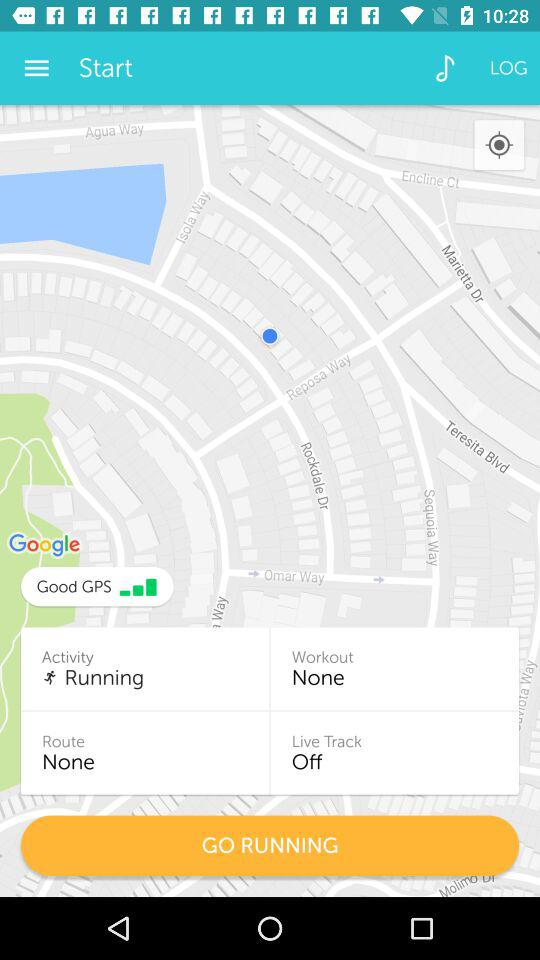What is the status of the "Live Track"? The status of the "Live Track" is "off". 